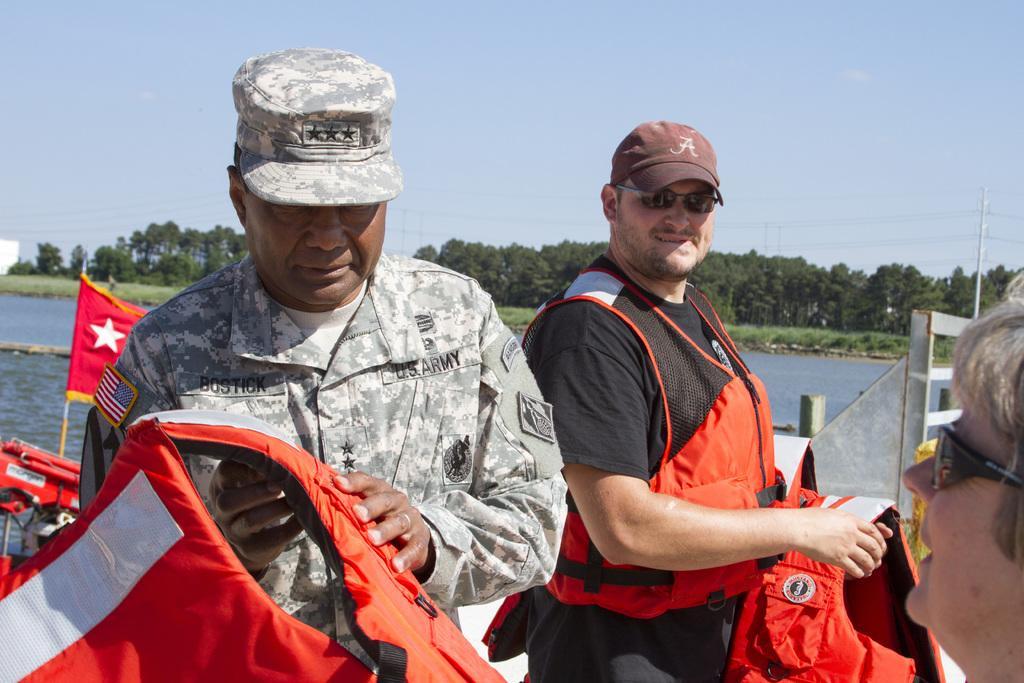In one or two sentences, can you explain what this image depicts? In the image there are three people, two men were holding swimming jackets with their hands behind them there is water surface and in the background there are many trees. 